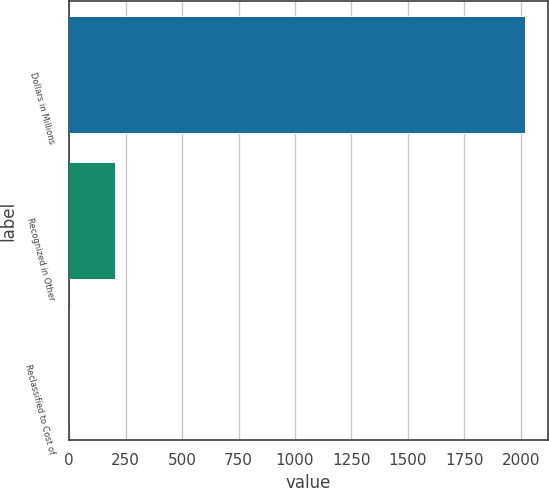<chart> <loc_0><loc_0><loc_500><loc_500><bar_chart><fcel>Dollars in Millions<fcel>Recognized in Other<fcel>Reclassified to Cost of<nl><fcel>2018<fcel>205.4<fcel>4<nl></chart> 